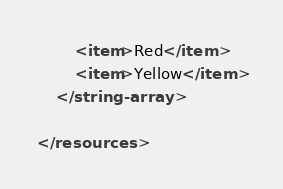<code> <loc_0><loc_0><loc_500><loc_500><_XML_>        <item>Red</item>
        <item>Yellow</item>
    </string-array>
    
</resources>
</code> 